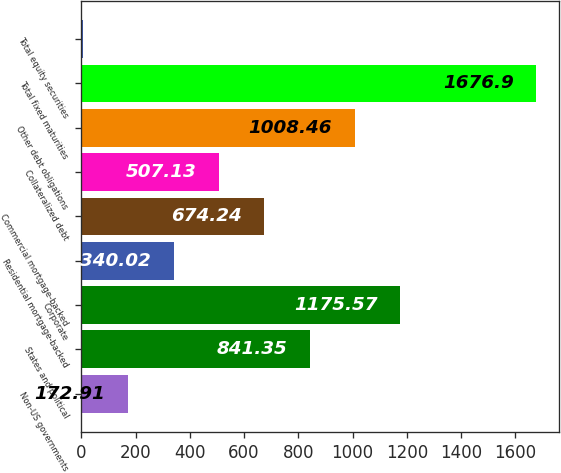<chart> <loc_0><loc_0><loc_500><loc_500><bar_chart><fcel>Non-US governments<fcel>States and political<fcel>Corporate<fcel>Residential mortgage-backed<fcel>Commercial mortgage-backed<fcel>Collateralized debt<fcel>Other debt obligations<fcel>Total fixed maturities<fcel>Total equity securities<nl><fcel>172.91<fcel>841.35<fcel>1175.57<fcel>340.02<fcel>674.24<fcel>507.13<fcel>1008.46<fcel>1676.9<fcel>5.8<nl></chart> 